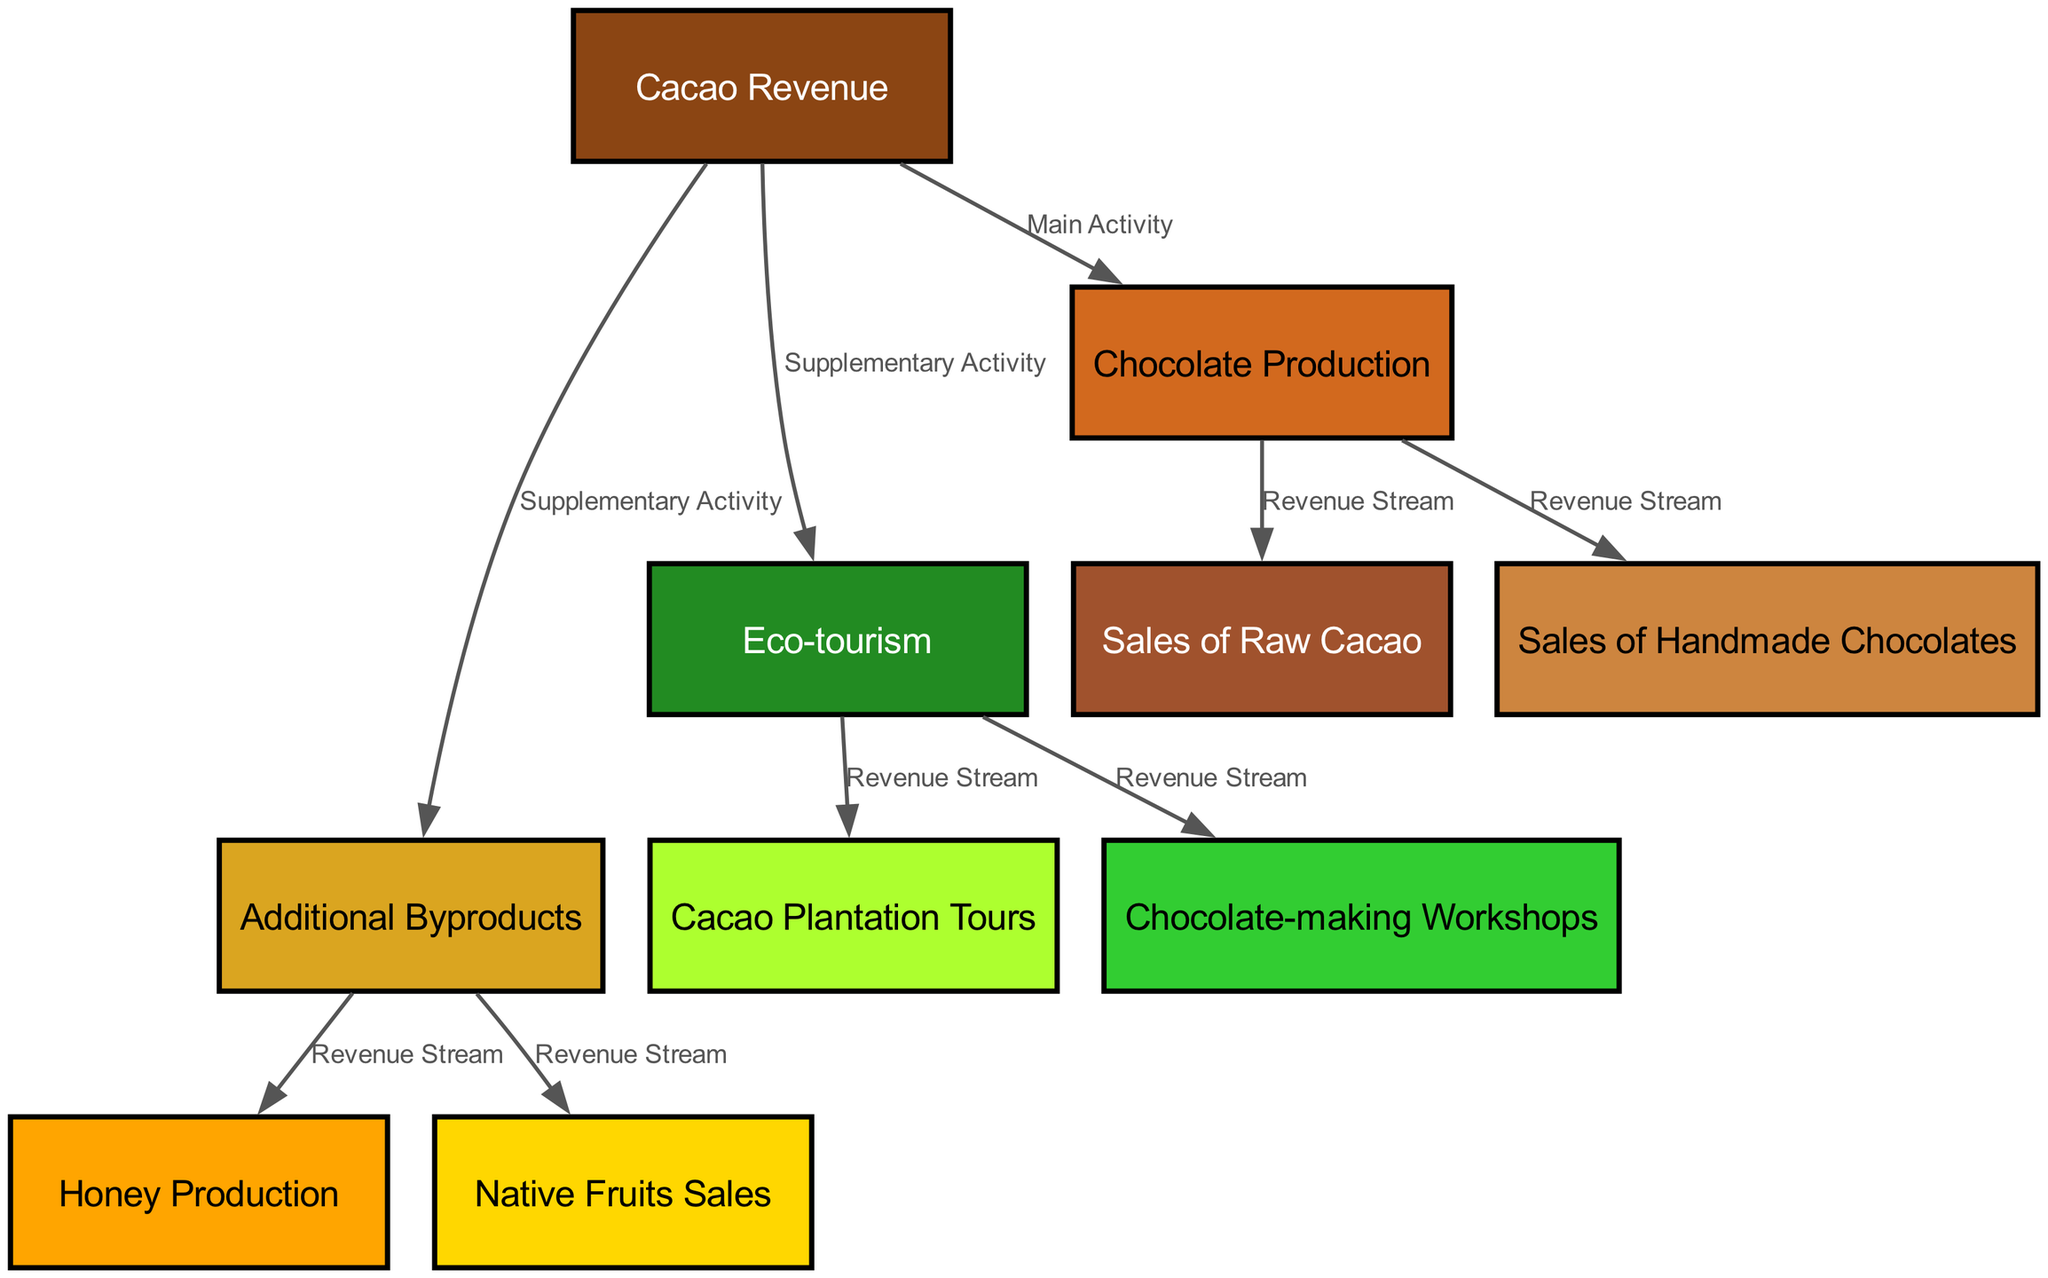What are the main activities generating revenue? The diagram indicates that the main activity generating revenue is "Chocolate Production" as shown by the direct connection from "Cacao Revenue" to "Chocolate Production" labeled as "Main Activity".
Answer: Chocolate Production What types of eco-tourism activities are represented? The diagram shows two connected nodes under eco-tourism: "Cacao Plantation Tours" and "Chocolate-making Workshops", both linked from "Eco-tourism" as revenue streams.
Answer: Cacao Plantation Tours, Chocolate-making Workshops How many revenue streams stem from chocolate production? Analyzing the edges leading from "Chocolate Production," there are two revenue streams: "Sales of Raw Cacao" and "Sales of Handmade Chocolates," giving a total of two.
Answer: 2 Which activity has supplementary income aside from cacao production? The diagram indicates that "Eco-tourism" and "Additional Byproducts" both supplement the main activity of cacao revenue, as they are labeled "Supplementary Activity" linked from "Cacao Revenue".
Answer: Eco-tourism, Additional Byproducts What is the relationship between additional byproducts and honey production? In the diagram, there's a direct edge labeled "Revenue Stream" connecting "Additional Byproducts" to "Honey Production", indicating that honey production is a source of revenue derived from additional byproducts.
Answer: Revenue Stream How many total nodes are present in the diagram? The total count of nodes visible in the diagram can be obtained by summing all individual nodes listed, which totals to ten nodes.
Answer: 10 What is the color representing sales of handmade chocolates? The node "Sales of Handmade Chocolates" is colored "#CD853F", which can be identified visually in the diagram.
Answer: #CD853F What are the revenue streams categorized under additional byproducts? There are two revenue streams connected to the "Additional Byproducts": "Honey Production" and "Native Fruits Sales," which can be seen linked by edges labeled "Revenue Stream".
Answer: Honey Production, Native Fruits Sales What type of diagram is shown for representing revenue breakdown? The diagram used here is a "Textbook Diagram," specifically structured to break down revenue sources clearly and visually, including nodes and labeled edges.
Answer: Textbook Diagram 